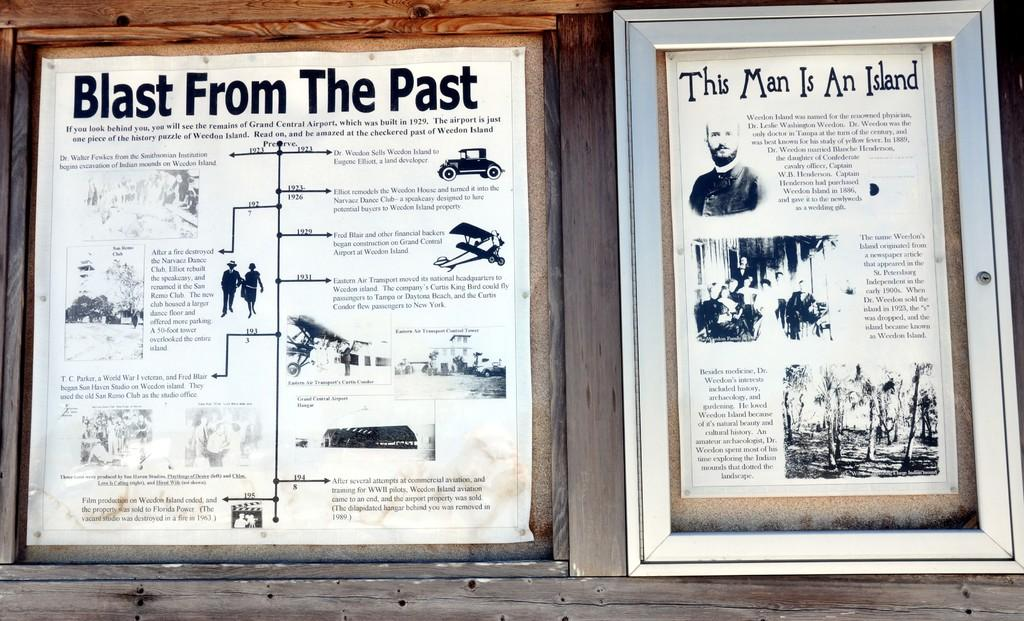<image>
Create a compact narrative representing the image presented. Two framed images that have a blast from the pas and this man is an island as titles. 